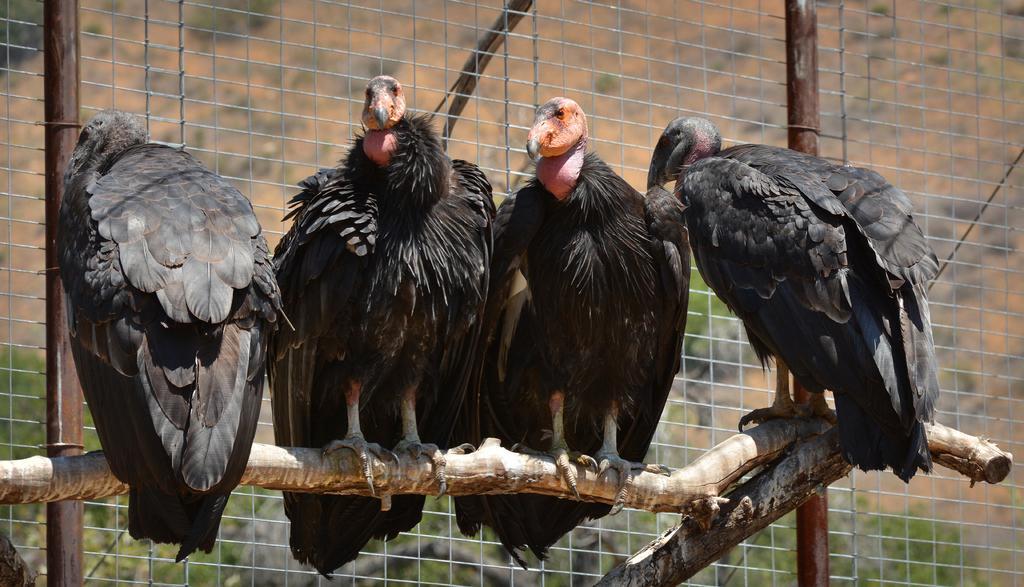Can you describe this image briefly? In the center of the picture we can see falcons, on the wooden log. In the middle we can see fencing. In the background there are trees and soil. 